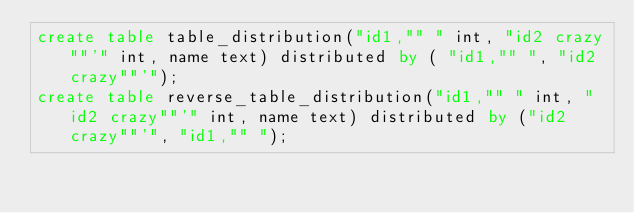Convert code to text. <code><loc_0><loc_0><loc_500><loc_500><_SQL_>create table table_distribution("id1,"" " int, "id2 crazy""'" int, name text) distributed by ( "id1,"" ", "id2 crazy""'");
create table reverse_table_distribution("id1,"" " int, "id2 crazy""'" int, name text) distributed by ("id2 crazy""'", "id1,"" ");
</code> 